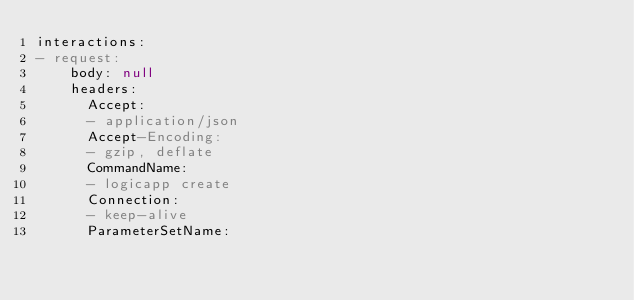<code> <loc_0><loc_0><loc_500><loc_500><_YAML_>interactions:
- request:
    body: null
    headers:
      Accept:
      - application/json
      Accept-Encoding:
      - gzip, deflate
      CommandName:
      - logicapp create
      Connection:
      - keep-alive
      ParameterSetName:</code> 